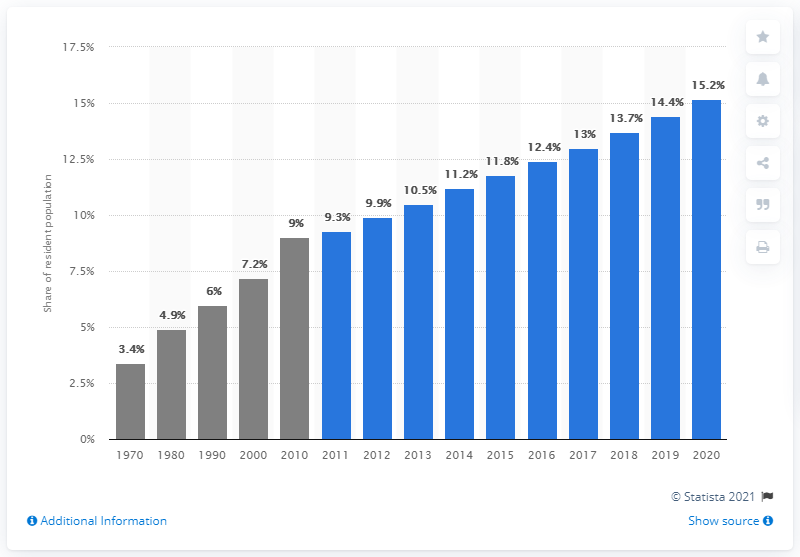Point out several critical features in this image. In 2020, approximately 15.2% of Singapore's population was aged 65 and above. 